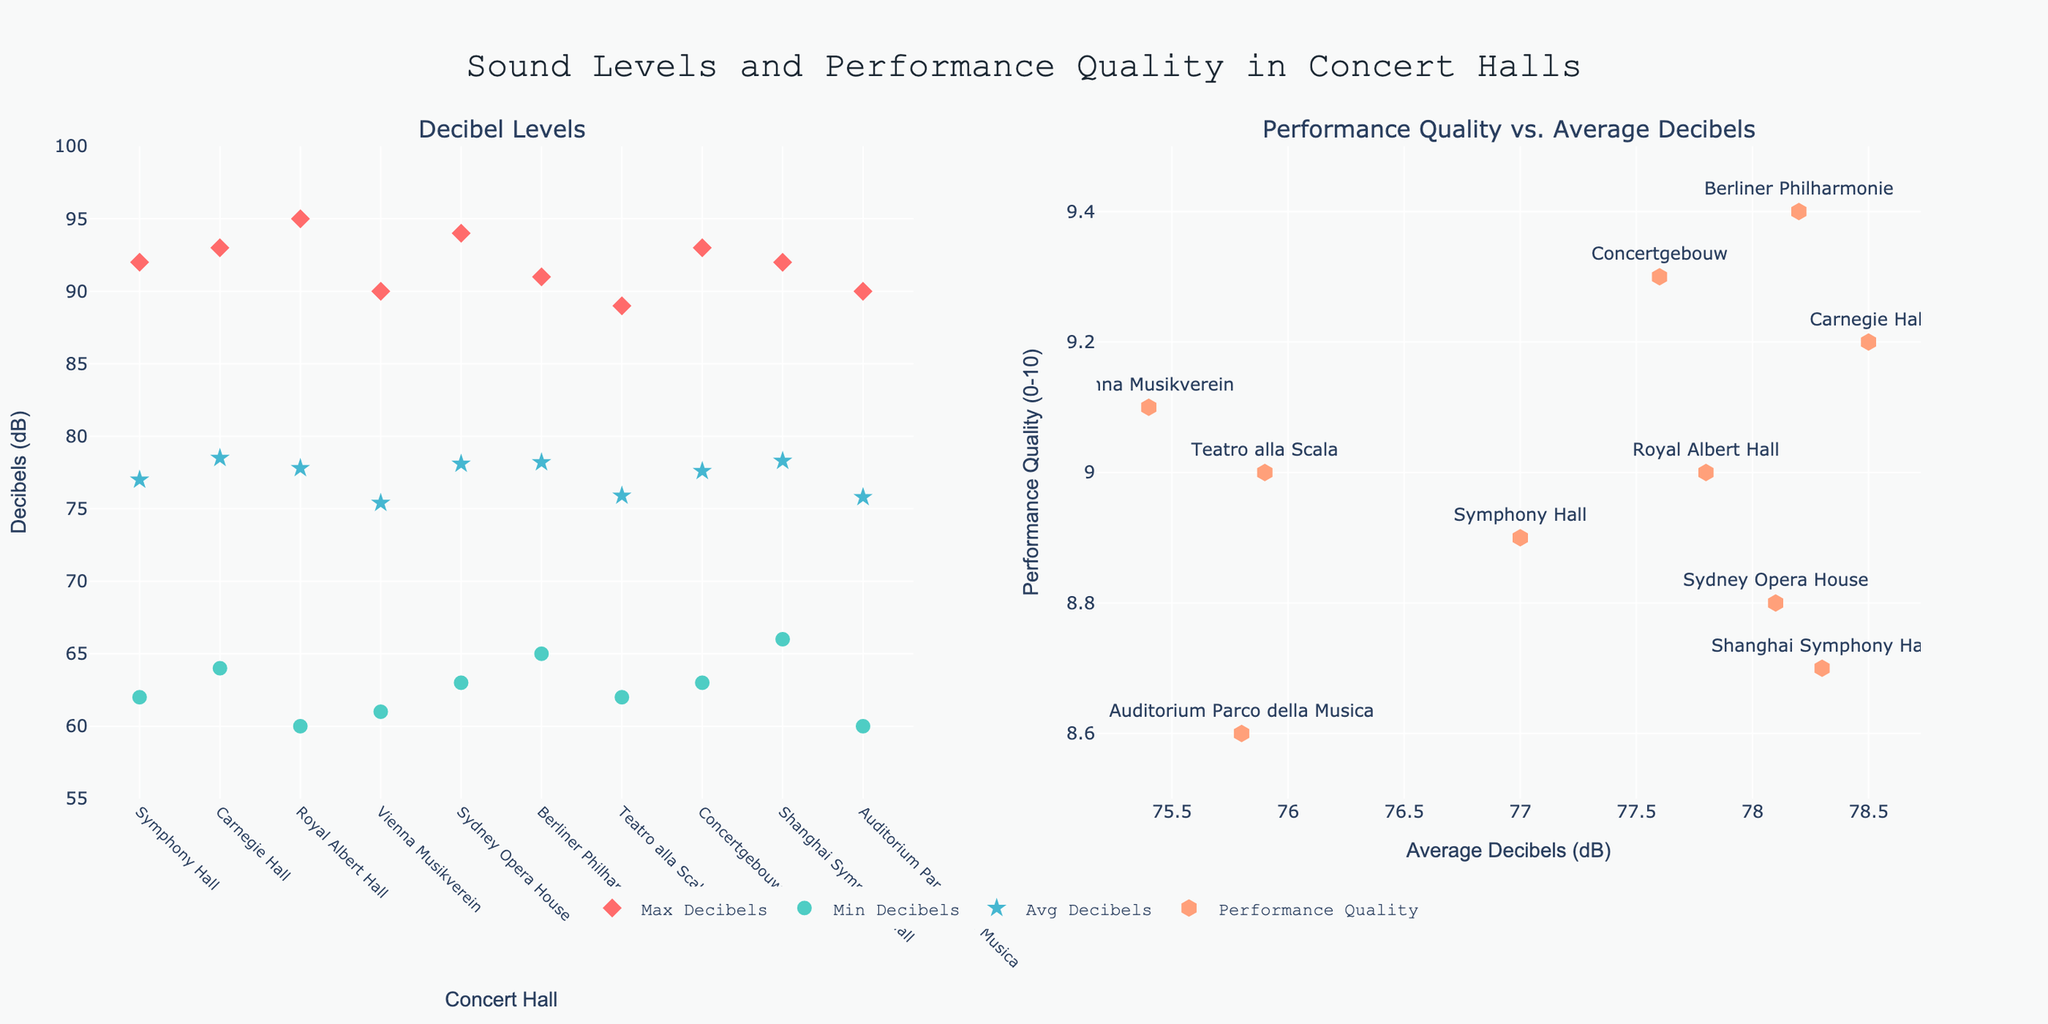How many concert halls are plotted in the Decibel Levels scatter plot? Count the number of unique points shown for each decibel category (Max, Min, Avg) in the first subplot. There are 10 concert halls, each represented by a point in the scatter plot.
Answer: 10 What are the maximum and minimum decibel levels measured at Carnegie Hall in New York? Look for the points specifically labeled for Carnegie Hall on the Decibel Levels scatter plot. The Max Decibels is 93, and the Min Decibels is 64 for Carnegie Hall.
Answer: Max: 93, Min: 64 Which concert hall has the highest performance quality? Identify the highest point on the Performance Quality vs. Average Decibels scatter plot, then check the label for that point. Berliner Philharmonie in Berlin has the highest performance quality with a value of 9.4.
Answer: Berliner Philharmonie Where does the Vienna Musikverein stand in terms of average decibels and performance quality? Locate the point labeled "Vienna Musikverein" on the Performance Quality vs. Average Decibels scatter plot. It has an Average Decibels of 75.4 and a Performance Quality of 9.1.
Answer: Avg Decibels: 75.4, Performance Quality: 9.1 What is the average of the maximum decibel levels across all listed concert halls? Sum all maximum decibel values and divide by the number of concert halls. (92 + 93 + 95 + 90 + 94 + 91 + 89 + 93 + 92 + 90) / 10 = 91.9
Answer: 91.9 How does Teatro alla Scala compare to Shanghai Symphony Hall in terms of performance quality? Compare the performance quality values for Teatro alla Scala and Shanghai Symphony Hall. Teatro alla Scala has a Performance Quality of 9.0, whereas Shanghai Symphony Hall has a Performance Quality of 8.7. Teatro alla Scala has a higher performance quality.
Answer: Teatro alla Scala is higher What is the range of performance quality values observed across the concert halls? Find the difference between the highest and lowest observed performance quality values on the Performance Quality vs. Average Decibels scatter plot. The range is 9.4 (highest) - 8.6 (lowest) = 0.8.
Answer: 0.8 Which concert hall has both high average decibels and high performance quality? Seek out concert halls with Avg Decibels near the upper end of the range (around high 70s) with a Performance Quality above 9. Concertgebouw in Amsterdam stands out with Avg Decibels of 77.6 and a Performance Quality of 9.3.
Answer: Concertgebouw 